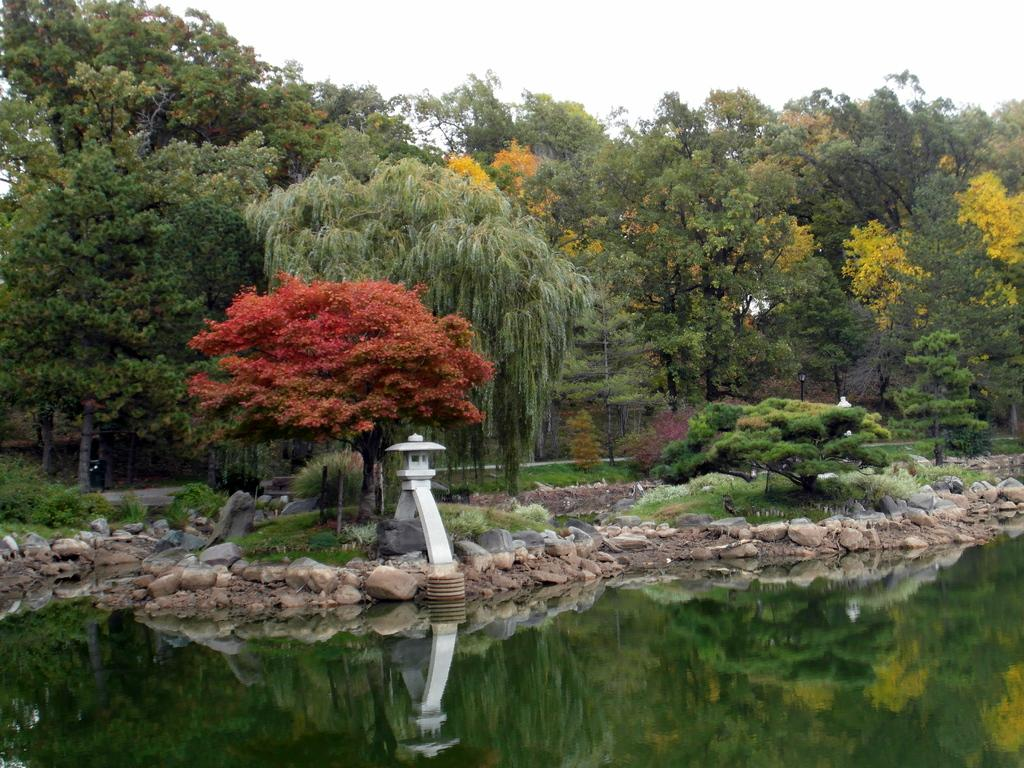What is located at the bottom of the image? There is a pond at the bottom of the image. What can be seen in the background of the image? There is a pole, trees, and the sky visible in the background of the image. What type of natural elements are present in the image? There are stones visible in the image. Where is the party taking place in the image? There is no party present in the image. What type of insect can be seen flying near the pond in the image? There are no insects visible in the image. 